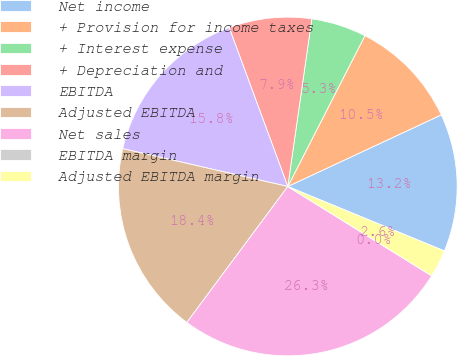Convert chart to OTSL. <chart><loc_0><loc_0><loc_500><loc_500><pie_chart><fcel>Net income<fcel>+ Provision for income taxes<fcel>+ Interest expense<fcel>+ Depreciation and<fcel>EBITDA<fcel>Adjusted EBITDA<fcel>Net sales<fcel>EBITDA margin<fcel>Adjusted EBITDA margin<nl><fcel>13.16%<fcel>10.53%<fcel>5.26%<fcel>7.89%<fcel>15.79%<fcel>18.42%<fcel>26.32%<fcel>0.0%<fcel>2.63%<nl></chart> 